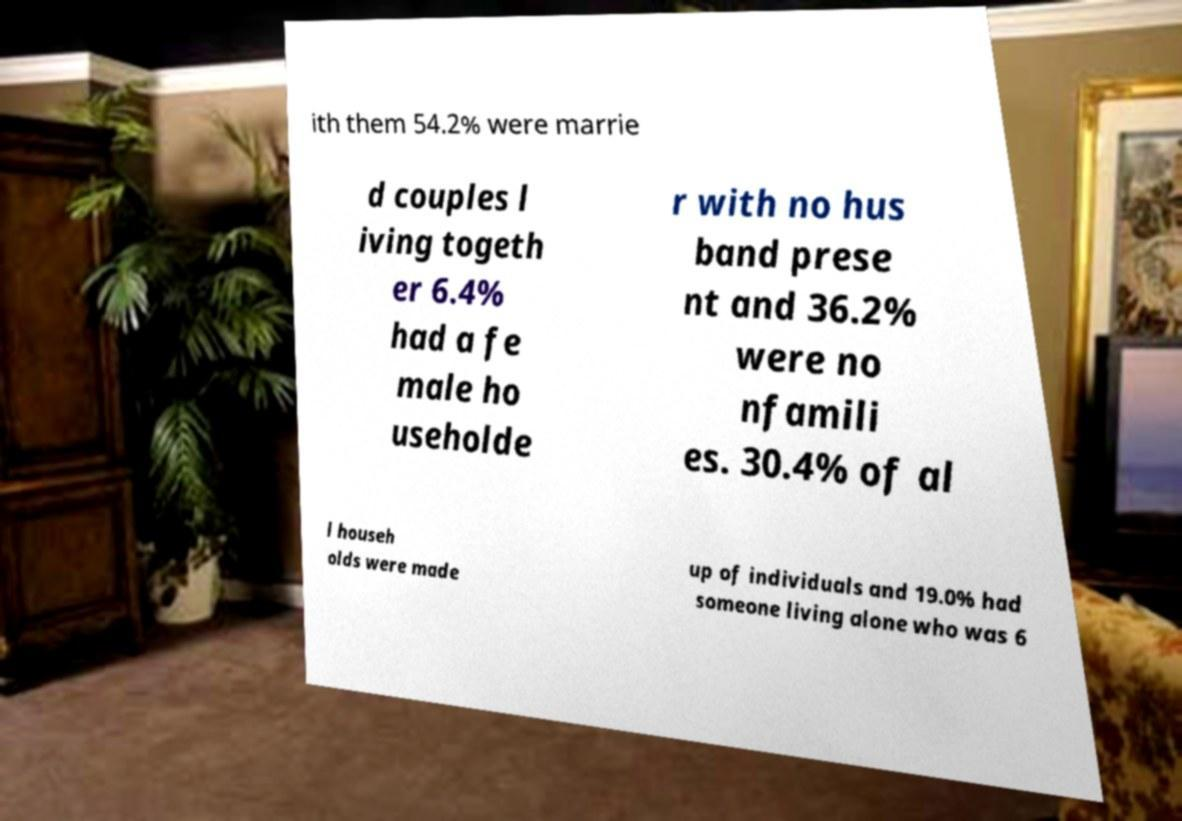I need the written content from this picture converted into text. Can you do that? ith them 54.2% were marrie d couples l iving togeth er 6.4% had a fe male ho useholde r with no hus band prese nt and 36.2% were no nfamili es. 30.4% of al l househ olds were made up of individuals and 19.0% had someone living alone who was 6 